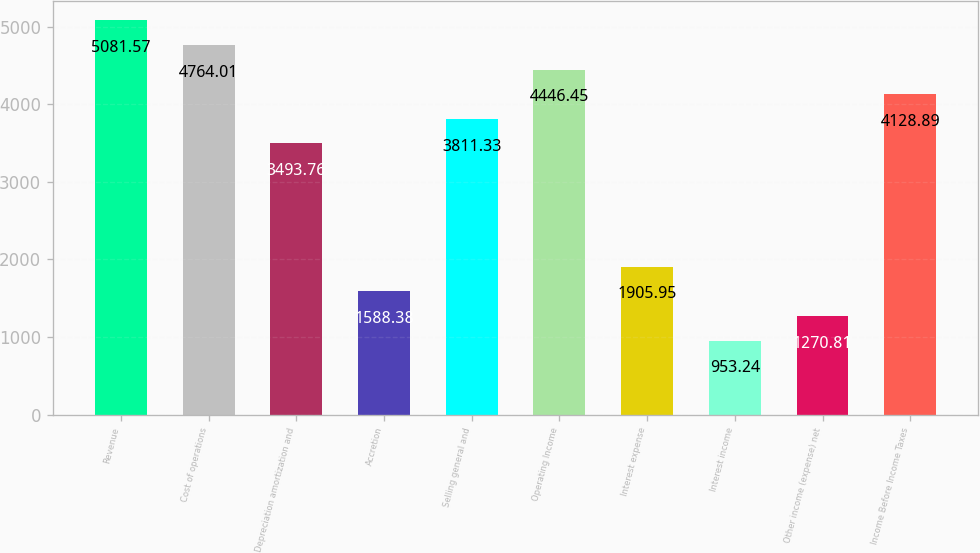Convert chart to OTSL. <chart><loc_0><loc_0><loc_500><loc_500><bar_chart><fcel>Revenue<fcel>Cost of operations<fcel>Depreciation amortization and<fcel>Accretion<fcel>Selling general and<fcel>Operating Income<fcel>Interest expense<fcel>Interest income<fcel>Other income (expense) net<fcel>Income Before Income Taxes<nl><fcel>5081.57<fcel>4764.01<fcel>3493.76<fcel>1588.38<fcel>3811.33<fcel>4446.45<fcel>1905.95<fcel>953.24<fcel>1270.81<fcel>4128.89<nl></chart> 